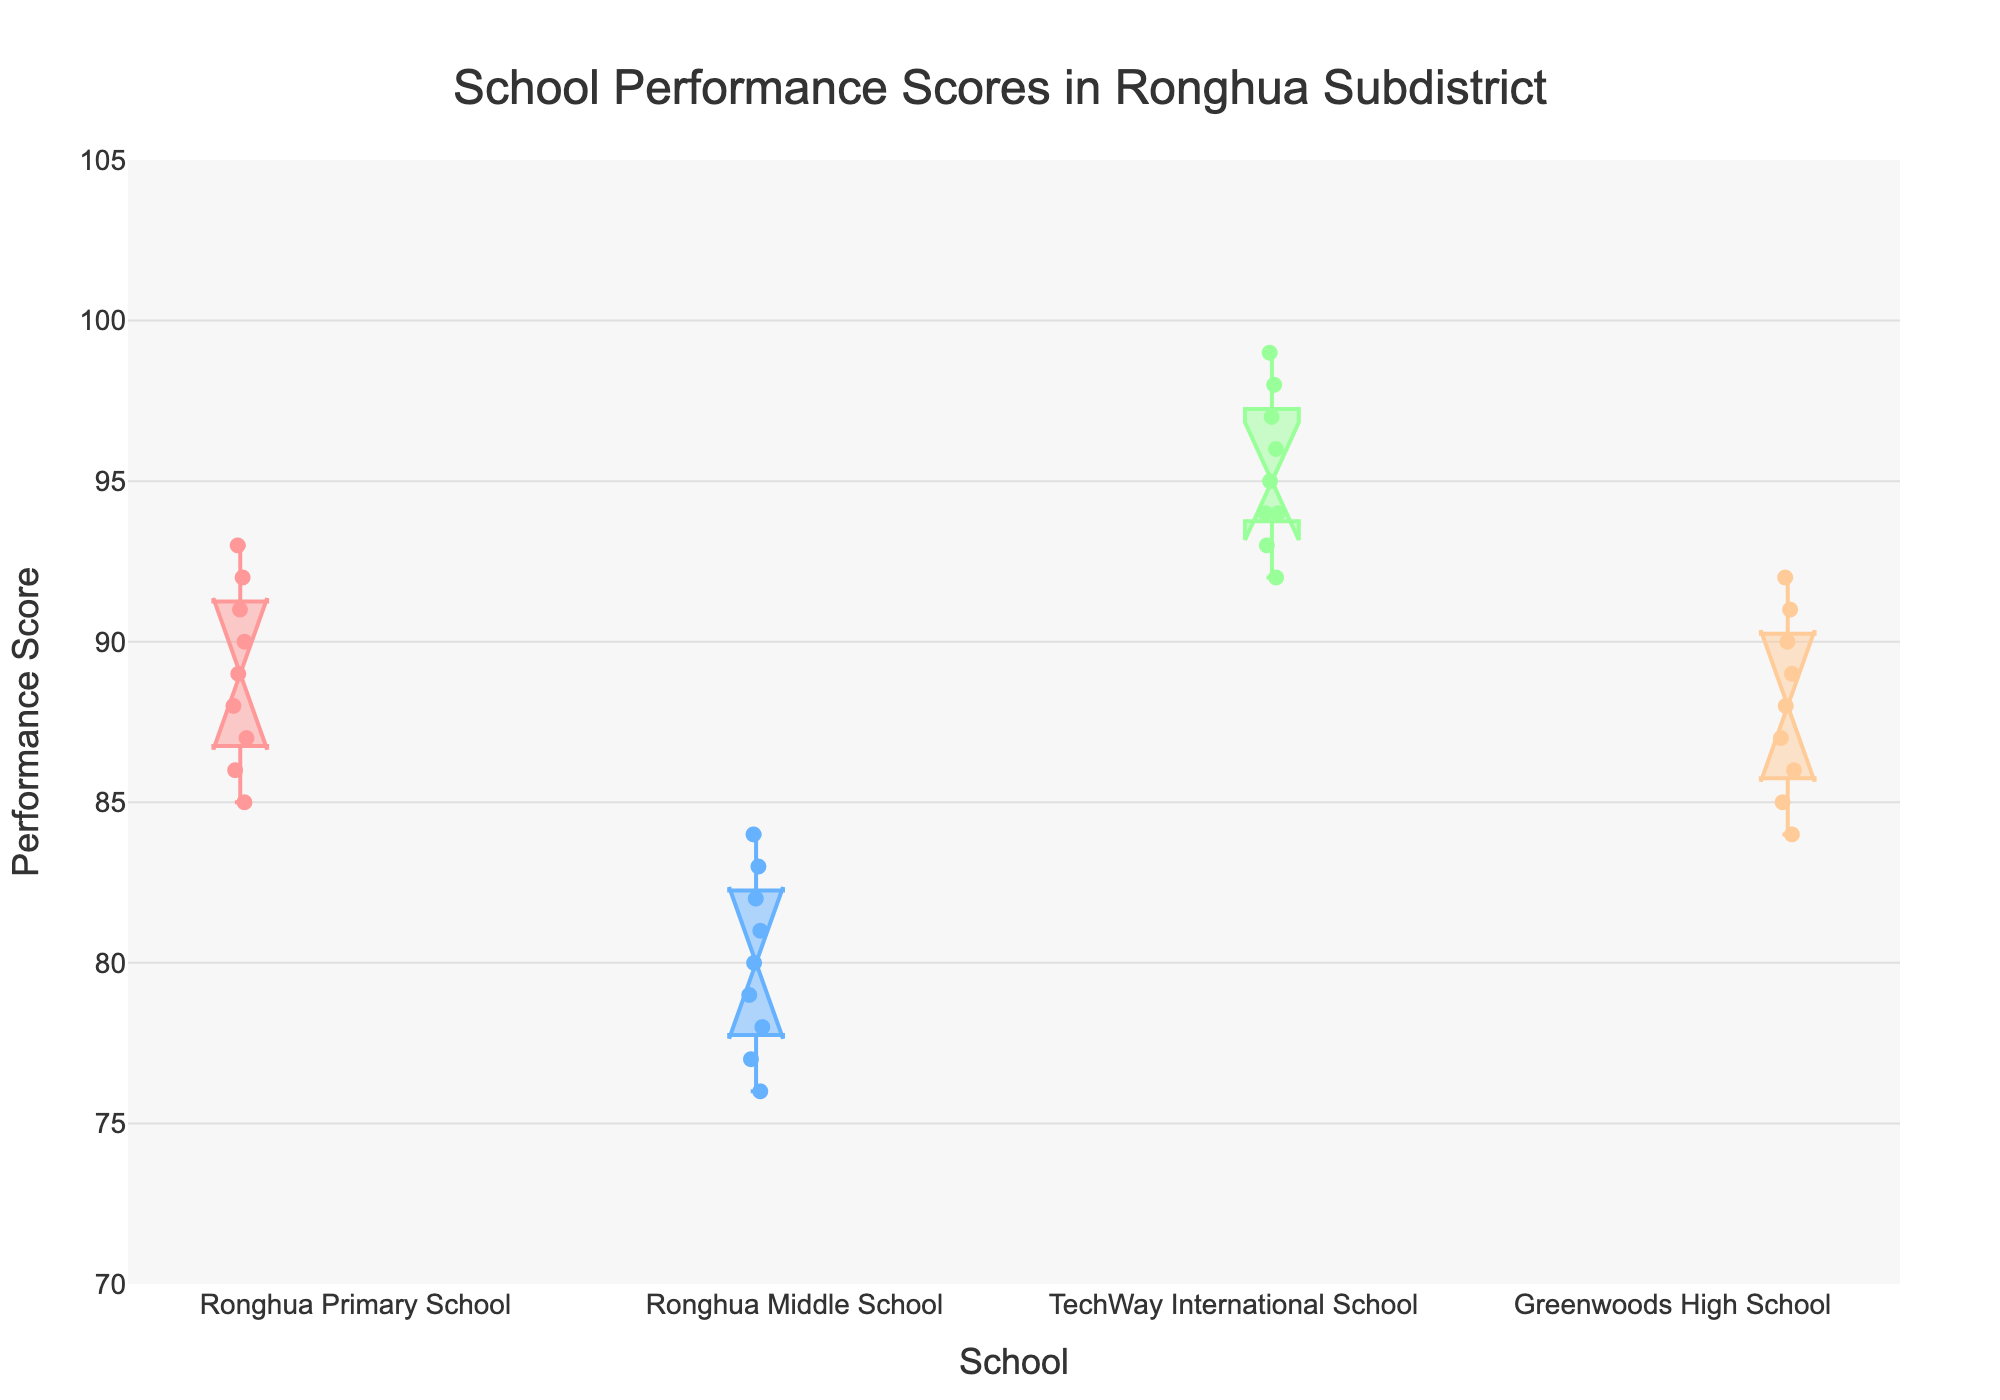what are the performance scores for Greenwoods High School? The plot shows data points distributed along the vertical axis aligned with Greenwoods High School, ranging from around 84 to 92.
Answer: 84 to 92 Which school has the highest median performance score? Median scores can be identified by the line within the boxes. TechWay International School has the line positioned at 95, higher than those of other schools.
Answer: TechWay International School What is the range of performance scores for Ronghua Middle School? The whiskers and data points show Ronghua Middle School's scores range from 76 to 84.
Answer: 76 to 84 Among the schools, which one has the widest range of performance scores? The widest range is identified by looking at the longest whisker span. TechWay International School ranges from 92 to 99 which is 7 points.
Answer: TechWay International School How do the performance scores of Ronghua Primary School compare with those of Greenwoods High School? The middle 50% of Ronghua Primary School's scores span from 86 to 91, whereas Greenwoods High School spans from 85 to 90. Both have a similar range, but Ronghua has a higher maximum (93).
Answer: Comparable, Ronghua has a bit higher variance and maximum score What does the notch in a Notched Box Plot represent? The notch in a box plot represents the confidence interval around the median, giving an idea of the significance of the difference between medians. If notches do not overlap, it suggests medians are significantly different.
Answer: Confidence interval around the median Which school shows the least variability in its performance scores? Least variability can be identified by the narrowest interquartile range (IQR). Ronghua Middle School has the shortest distance between the top and bottom of the box (78 to 82).
Answer: Ronghua Middle School Which school has an outlier in performance scores? Outliers are usually plotted as individual points beyond the whiskers. None of the schools show outliers; all plotted scores fall within whisker bounds.
Answer: None What's the interquartile range (IQR) of performance scores for TechWay International School? IQR is the difference between Q3 and Q1 (upper and lower boundaries of the box). For TechWay, Q3 is around 98 and Q1 is around 93, so IQR is 98 - 93 = 5.
Answer: 5 Which school has the lowest minimum performance score? Examining the bottom of the whiskers, Ronghua Middle School has the lowest minimum score at 76.
Answer: Ronghua Middle School 